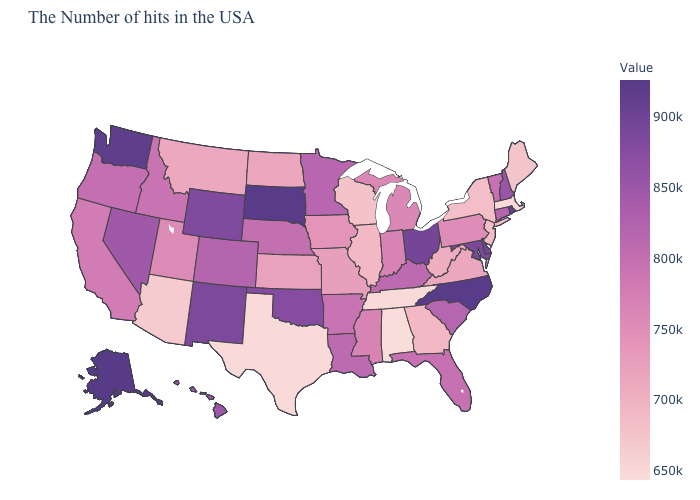Does Maryland have a higher value than North Carolina?
Answer briefly. No. Does Virginia have a lower value than Texas?
Concise answer only. No. Which states have the lowest value in the USA?
Keep it brief. Alabama. Which states have the lowest value in the USA?
Keep it brief. Alabama. Among the states that border Maryland , which have the highest value?
Give a very brief answer. Delaware. Among the states that border Massachusetts , which have the highest value?
Give a very brief answer. Rhode Island. Among the states that border California , does Nevada have the highest value?
Give a very brief answer. Yes. 